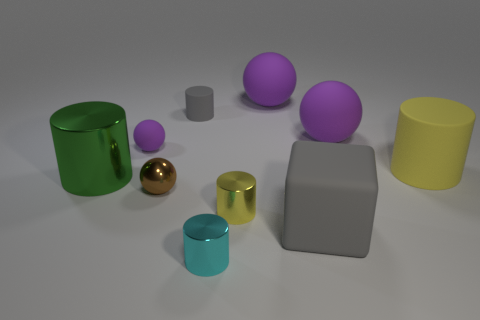What do the different textures in the image suggest to you? The diverse textures in the image are quite intriguing. The smoothness of the spheres contrasts with the more textured appearance of the cylinders. This variety of textures might imply a contrast between the objects, perhaps in an attempt to convey a sense of diversity, or to experiment with light and its varying reflections and effects on different surfaces.  Does the lighting tell you anything about the environment? The lighting in the image is soft and diffused, suggesting an evenly lit indoor environment. There are subtle shadows under the objects, indicating a light source that seems to be above and possibly slightly in front of the objects, offering a gentle illumination that enhances the three-dimensionality of the figures without creating harsh shadows. It could be representative of studio lighting, commonly used in visualization and rendering tests. 